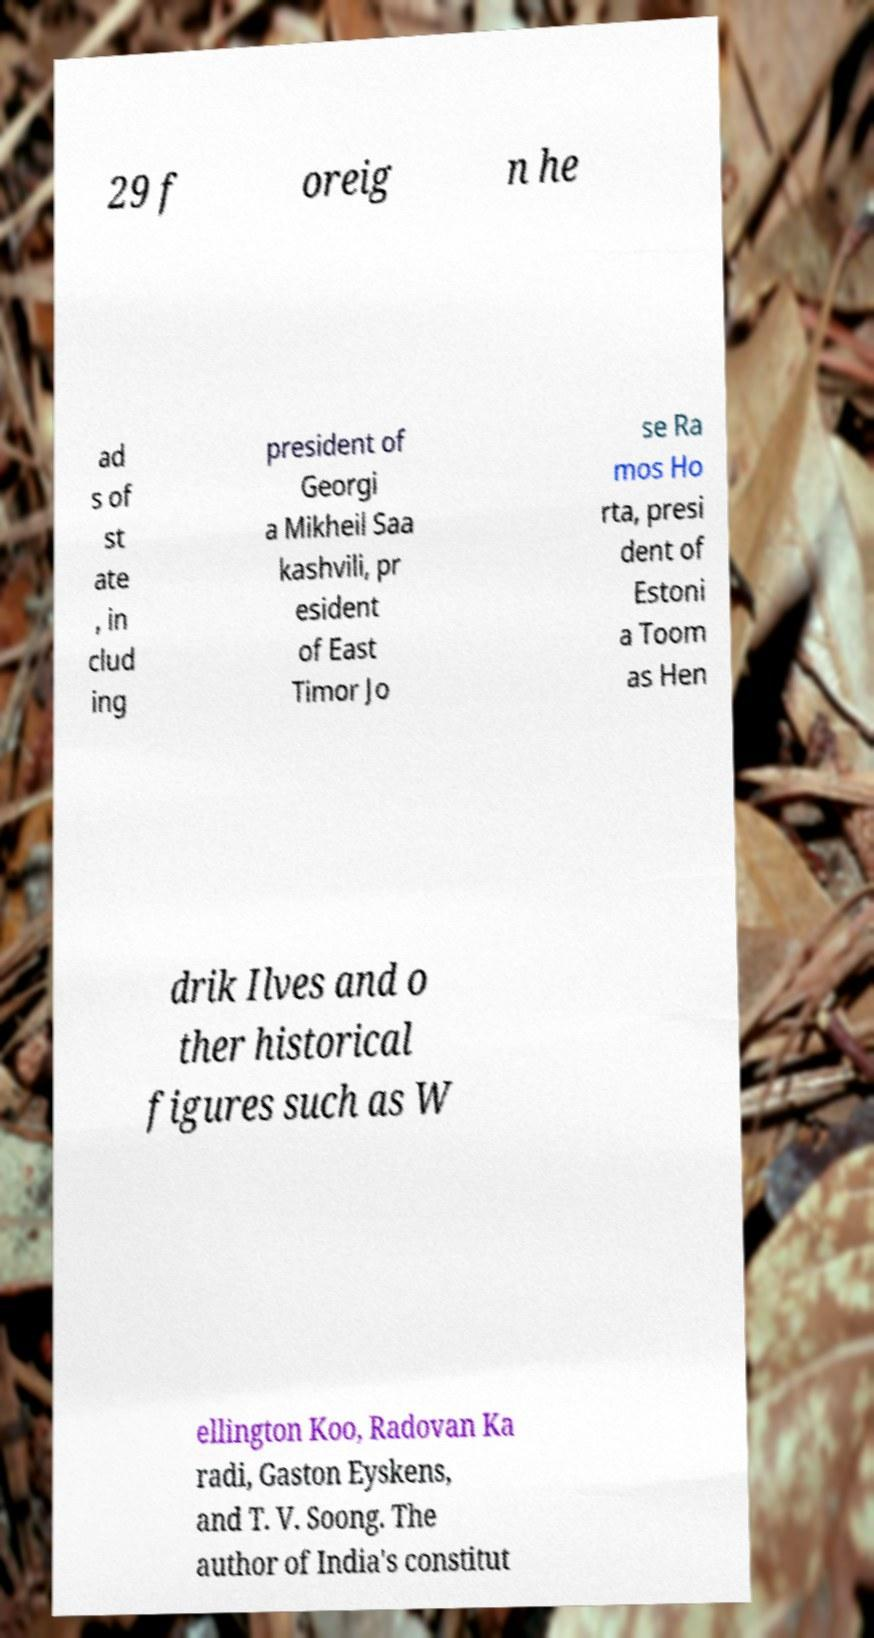Could you extract and type out the text from this image? 29 f oreig n he ad s of st ate , in clud ing president of Georgi a Mikheil Saa kashvili, pr esident of East Timor Jo se Ra mos Ho rta, presi dent of Estoni a Toom as Hen drik Ilves and o ther historical figures such as W ellington Koo, Radovan Ka radi, Gaston Eyskens, and T. V. Soong. The author of India's constitut 